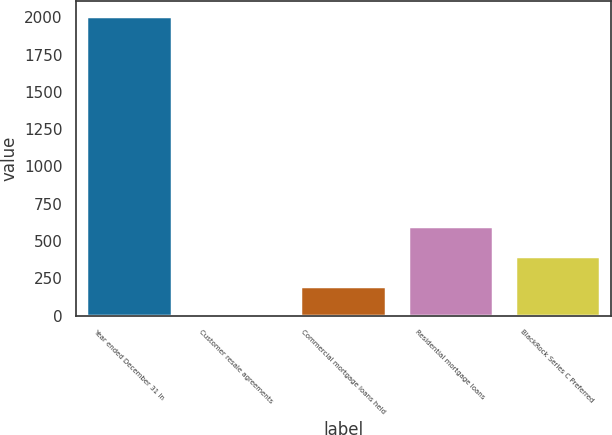Convert chart. <chart><loc_0><loc_0><loc_500><loc_500><bar_chart><fcel>Year ended December 31 In<fcel>Customer resale agreements<fcel>Commercial mortgage loans held<fcel>Residential mortgage loans<fcel>BlackRock Series C Preferred<nl><fcel>2010<fcel>1<fcel>201.9<fcel>603.7<fcel>402.8<nl></chart> 